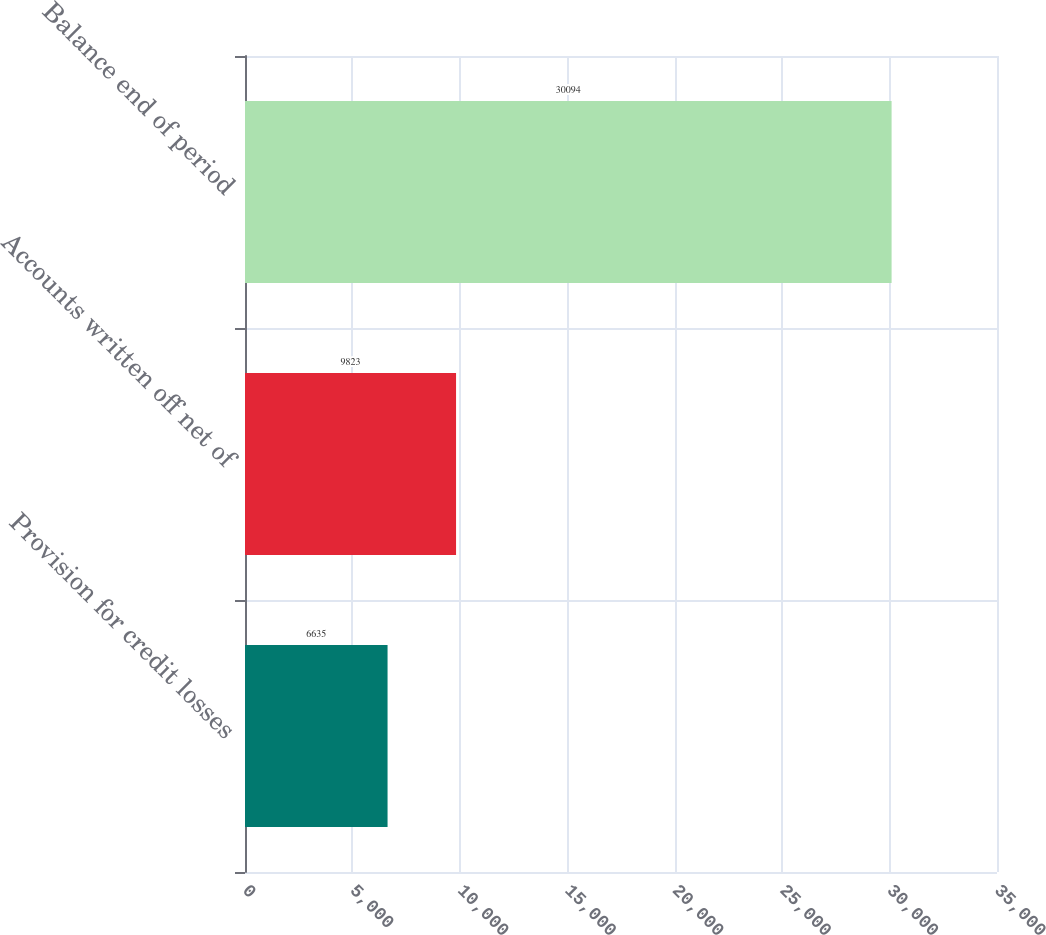Convert chart to OTSL. <chart><loc_0><loc_0><loc_500><loc_500><bar_chart><fcel>Provision for credit losses<fcel>Accounts written off net of<fcel>Balance end of period<nl><fcel>6635<fcel>9823<fcel>30094<nl></chart> 